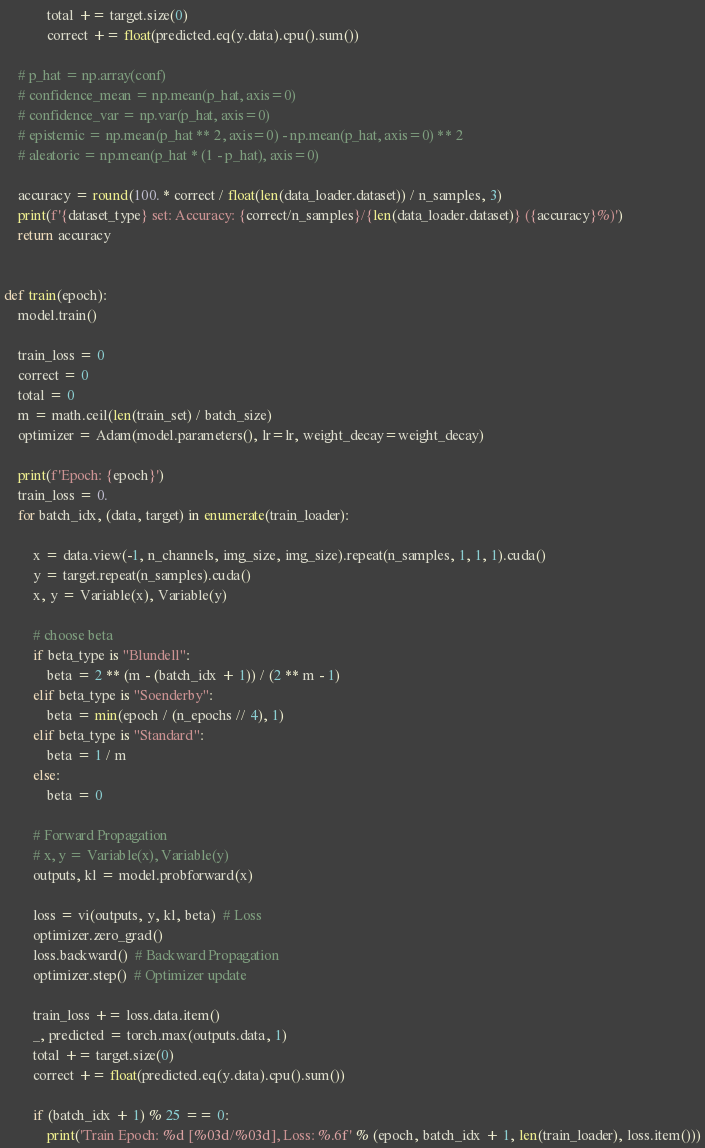<code> <loc_0><loc_0><loc_500><loc_500><_Python_>            total += target.size(0)
            correct += float(predicted.eq(y.data).cpu().sum())

    # p_hat = np.array(conf)
    # confidence_mean = np.mean(p_hat, axis=0)
    # confidence_var = np.var(p_hat, axis=0)
    # epistemic = np.mean(p_hat ** 2, axis=0) - np.mean(p_hat, axis=0) ** 2
    # aleatoric = np.mean(p_hat * (1 - p_hat), axis=0)

    accuracy = round(100. * correct / float(len(data_loader.dataset)) / n_samples, 3)
    print(f'{dataset_type} set: Accuracy: {correct/n_samples}/{len(data_loader.dataset)} ({accuracy}%)')
    return accuracy


def train(epoch):
    model.train()

    train_loss = 0
    correct = 0
    total = 0
    m = math.ceil(len(train_set) / batch_size)
    optimizer = Adam(model.parameters(), lr=lr, weight_decay=weight_decay)

    print(f'Epoch: {epoch}')
    train_loss = 0.
    for batch_idx, (data, target) in enumerate(train_loader):

        x = data.view(-1, n_channels, img_size, img_size).repeat(n_samples, 1, 1, 1).cuda()
        y = target.repeat(n_samples).cuda()
        x, y = Variable(x), Variable(y)

        # choose beta
        if beta_type is "Blundell":
            beta = 2 ** (m - (batch_idx + 1)) / (2 ** m - 1)
        elif beta_type is "Soenderby":
            beta = min(epoch / (n_epochs // 4), 1)
        elif beta_type is "Standard":
            beta = 1 / m
        else:
            beta = 0

        # Forward Propagation
        # x, y = Variable(x), Variable(y)
        outputs, kl = model.probforward(x)

        loss = vi(outputs, y, kl, beta)  # Loss
        optimizer.zero_grad()
        loss.backward()  # Backward Propagation
        optimizer.step()  # Optimizer update

        train_loss += loss.data.item()
        _, predicted = torch.max(outputs.data, 1)
        total += target.size(0)
        correct += float(predicted.eq(y.data).cpu().sum())

        if (batch_idx + 1) % 25 == 0:
            print('Train Epoch: %d [%03d/%03d], Loss: %.6f' % (epoch, batch_idx + 1, len(train_loader), loss.item()))</code> 